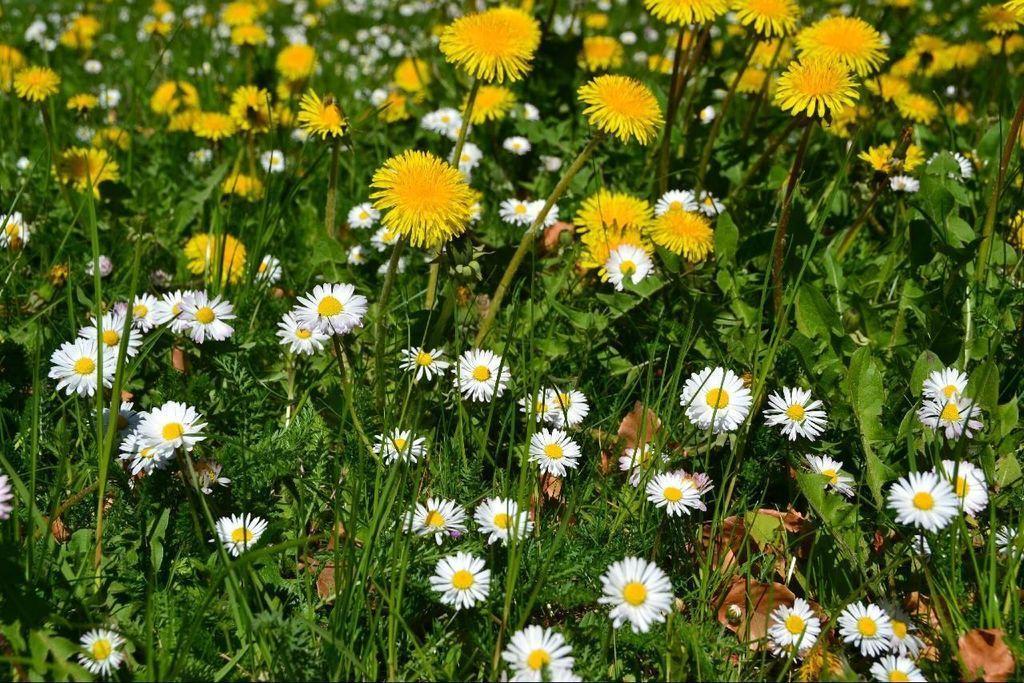Please provide a concise description of this image. In this picture I can see plants with yellow and white flowers. 